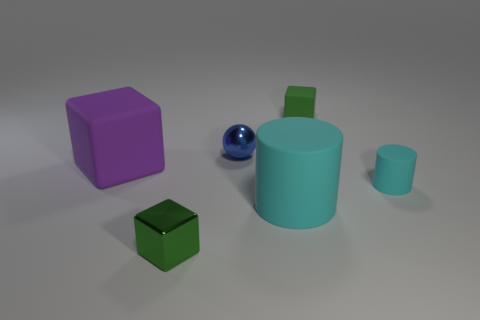Add 2 cyan matte things. How many objects exist? 8 Subtract all tiny cubes. How many cubes are left? 1 Subtract all purple blocks. How many blocks are left? 2 Subtract 2 cubes. How many cubes are left? 1 Subtract all gray cylinders. How many green blocks are left? 2 Subtract all blue metallic things. Subtract all large matte cylinders. How many objects are left? 4 Add 6 small blue shiny balls. How many small blue shiny balls are left? 7 Add 1 small purple shiny objects. How many small purple shiny objects exist? 1 Subtract 0 red spheres. How many objects are left? 6 Subtract all cylinders. How many objects are left? 4 